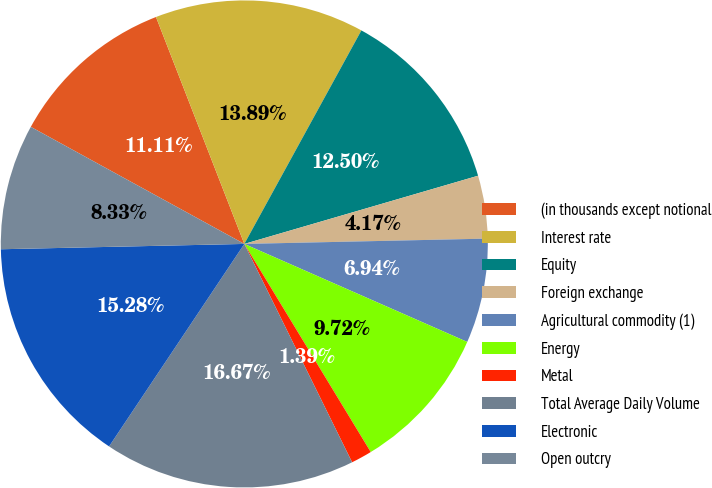Convert chart. <chart><loc_0><loc_0><loc_500><loc_500><pie_chart><fcel>(in thousands except notional<fcel>Interest rate<fcel>Equity<fcel>Foreign exchange<fcel>Agricultural commodity (1)<fcel>Energy<fcel>Metal<fcel>Total Average Daily Volume<fcel>Electronic<fcel>Open outcry<nl><fcel>11.11%<fcel>13.89%<fcel>12.5%<fcel>4.17%<fcel>6.94%<fcel>9.72%<fcel>1.39%<fcel>16.67%<fcel>15.28%<fcel>8.33%<nl></chart> 